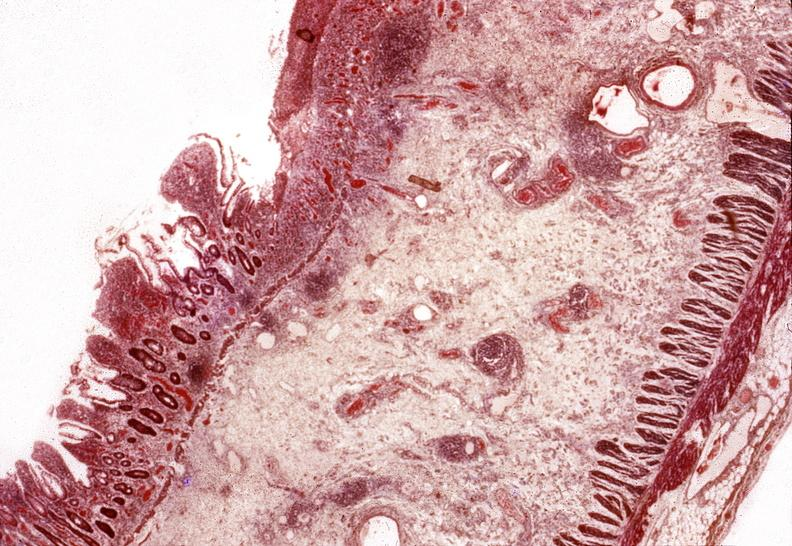what is present?
Answer the question using a single word or phrase. Gastrointestinal 